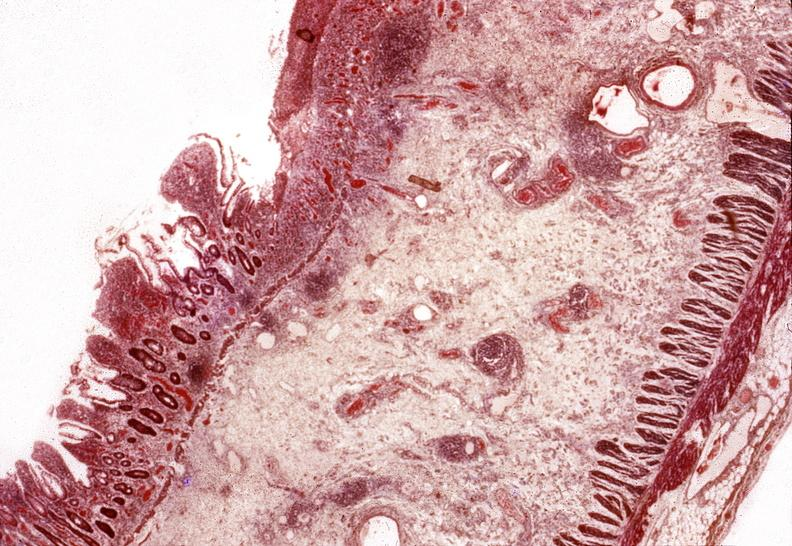what is present?
Answer the question using a single word or phrase. Gastrointestinal 